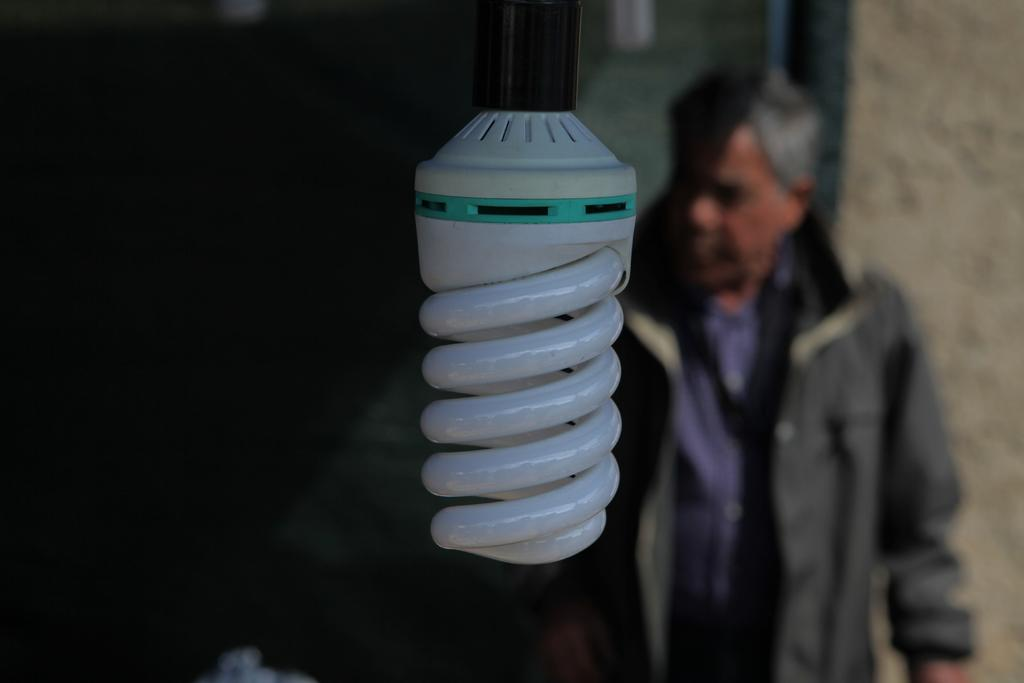What type of light bulb is visible in the image? There is a white color light bulb in the image. Can you describe the background of the image? There is a man standing in the background of the image, and there is also a wall. How many people are present in the image? There is one man present in the image. How many grapes are on the table in the image? There is no table or grapes present in the image. What type of rifle is the man holding in the image? There is no rifle present in the image; the man is not holding any object. 